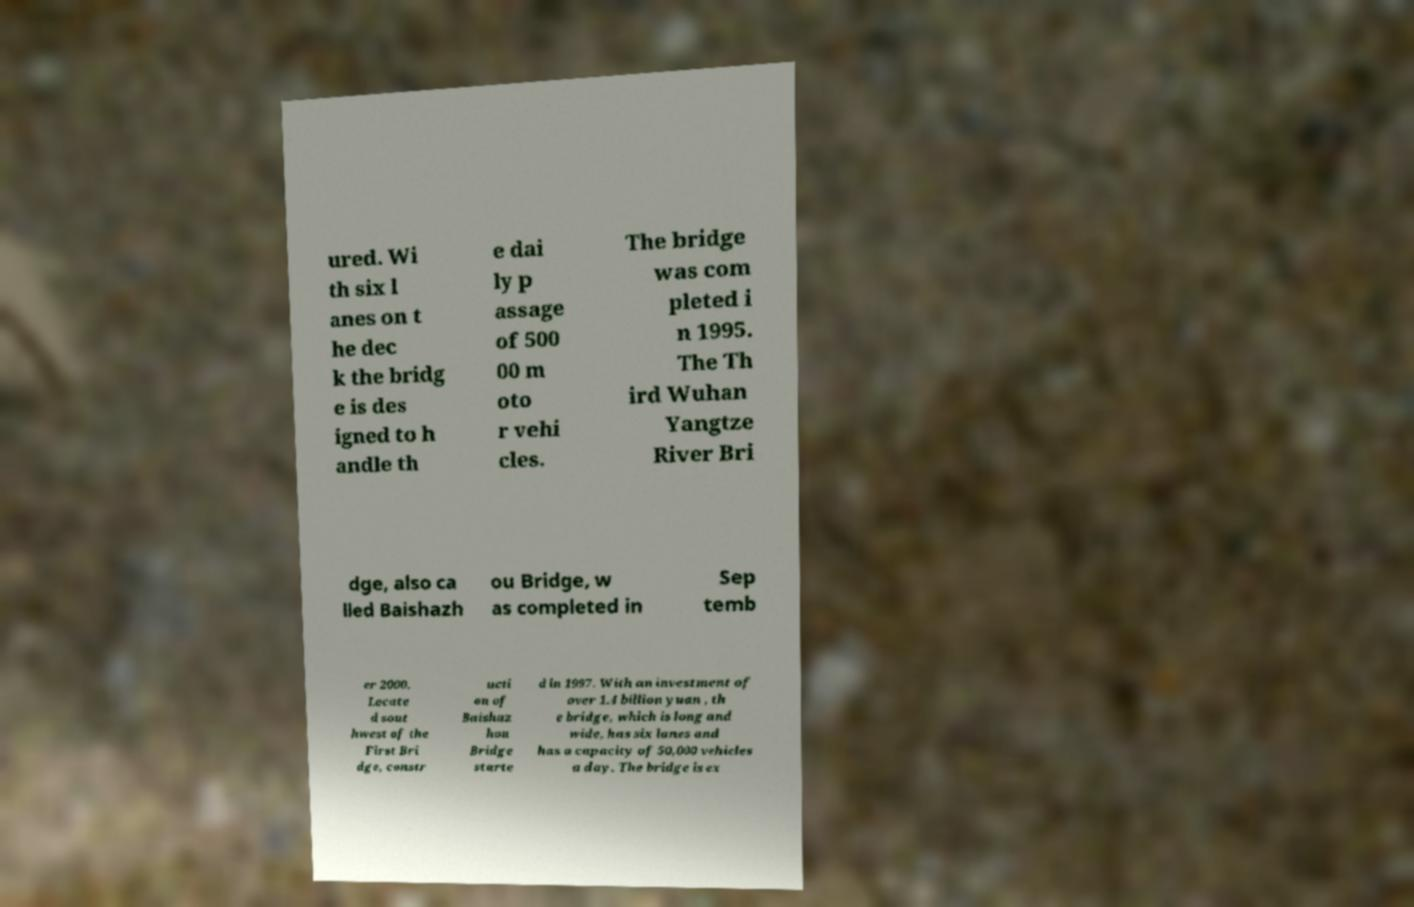Can you read and provide the text displayed in the image?This photo seems to have some interesting text. Can you extract and type it out for me? ured. Wi th six l anes on t he dec k the bridg e is des igned to h andle th e dai ly p assage of 500 00 m oto r vehi cles. The bridge was com pleted i n 1995. The Th ird Wuhan Yangtze River Bri dge, also ca lled Baishazh ou Bridge, w as completed in Sep temb er 2000. Locate d sout hwest of the First Bri dge, constr ucti on of Baishaz hou Bridge starte d in 1997. With an investment of over 1.4 billion yuan , th e bridge, which is long and wide, has six lanes and has a capacity of 50,000 vehicles a day. The bridge is ex 